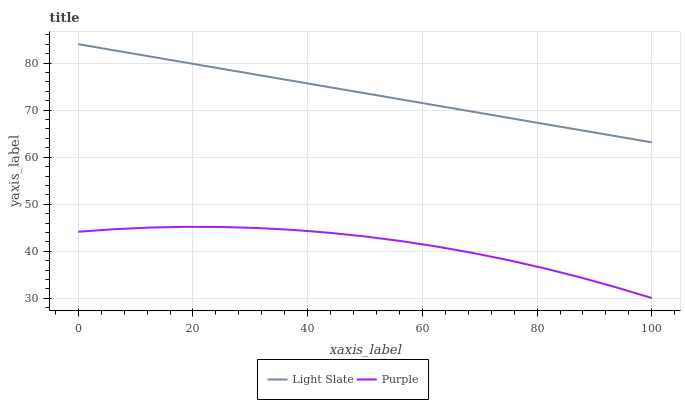Does Purple have the minimum area under the curve?
Answer yes or no. Yes. Does Purple have the maximum area under the curve?
Answer yes or no. No. Is Purple the smoothest?
Answer yes or no. No. Does Purple have the highest value?
Answer yes or no. No. Is Purple less than Light Slate?
Answer yes or no. Yes. Is Light Slate greater than Purple?
Answer yes or no. Yes. Does Purple intersect Light Slate?
Answer yes or no. No. 